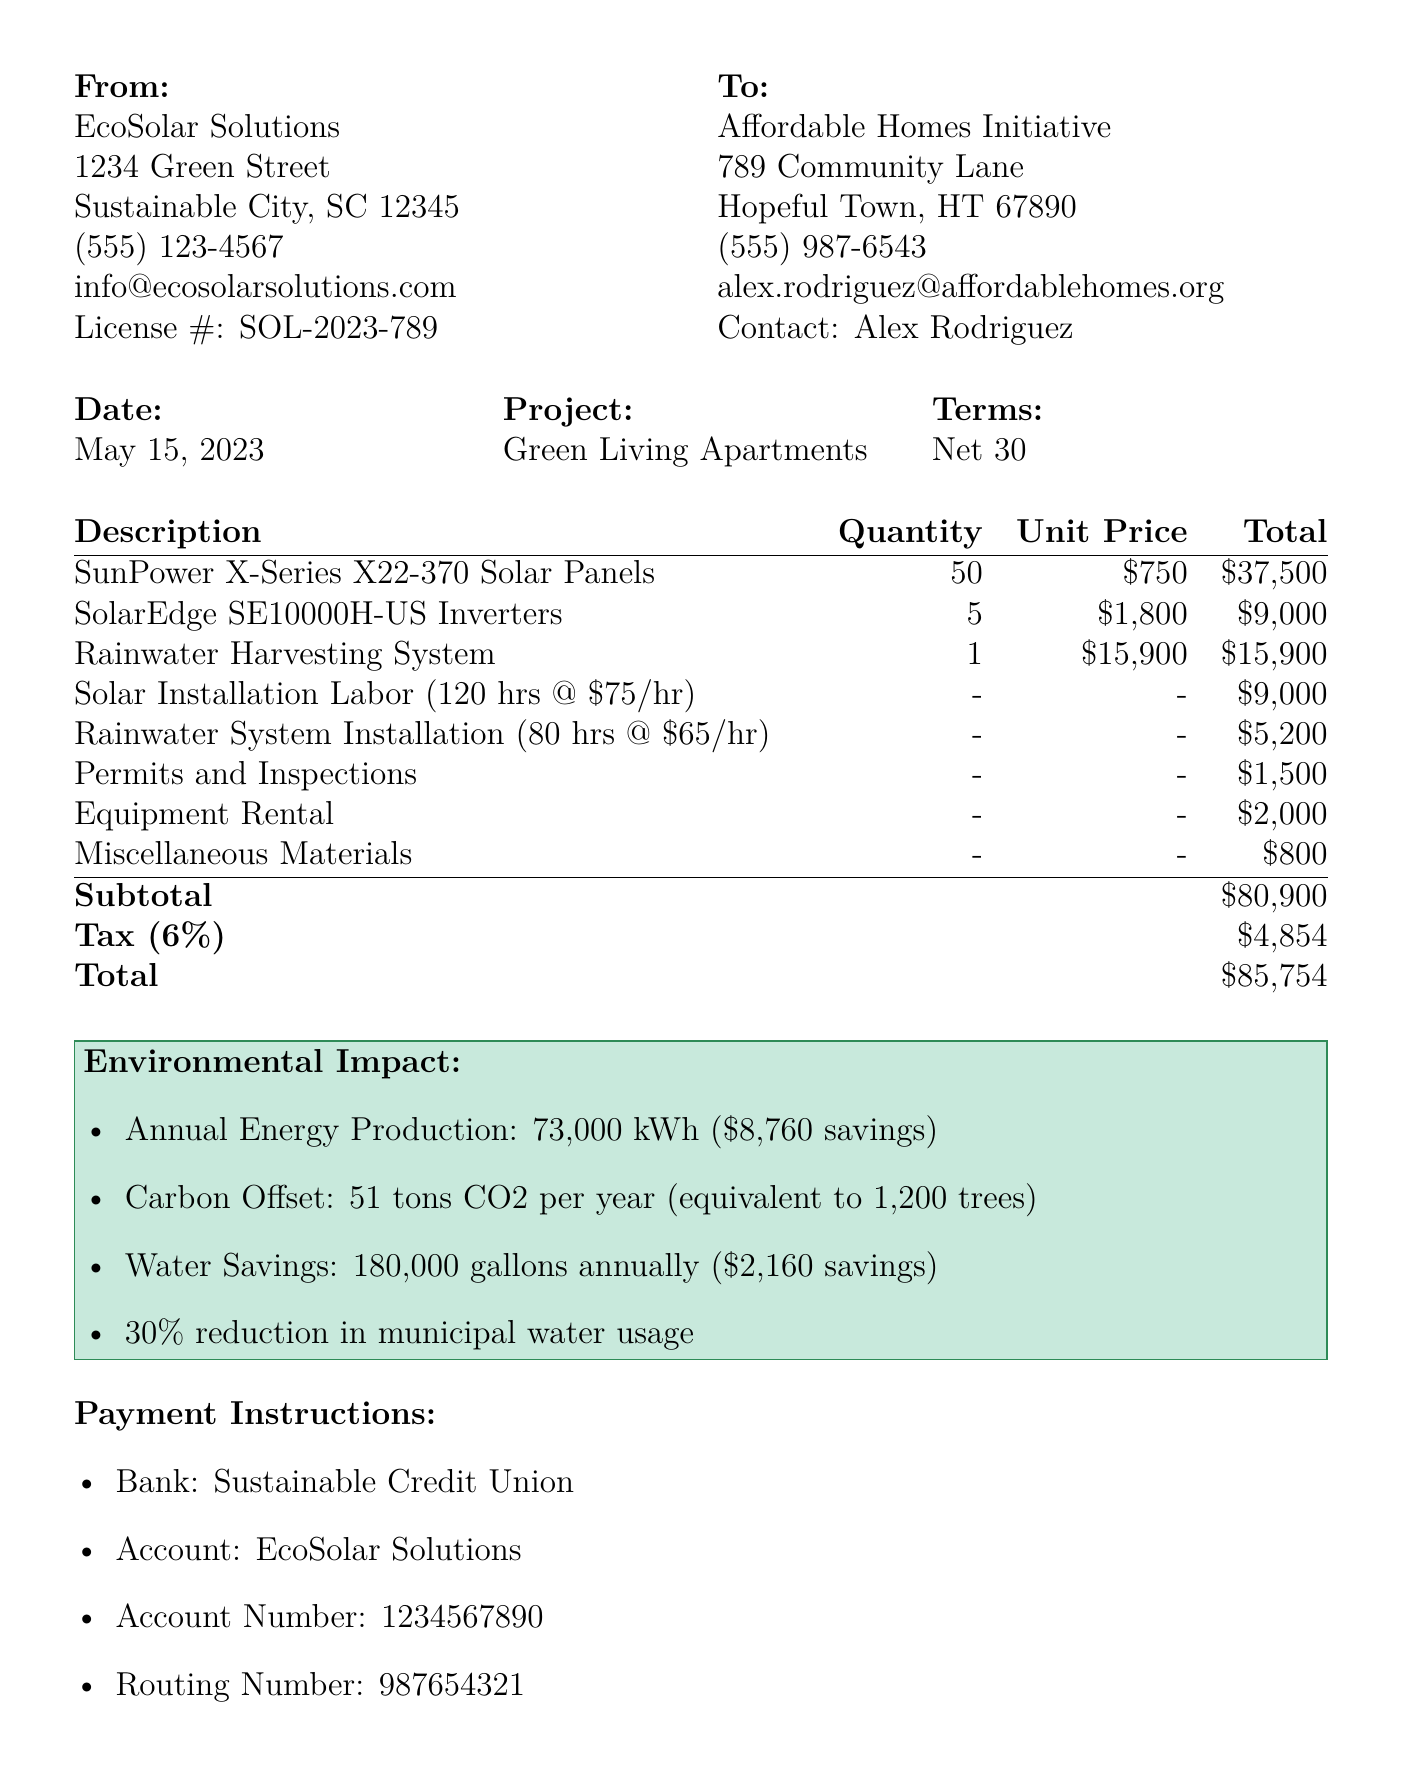What is the invoice number? The invoice number is specified under the invoice details section of the document.
Answer: INV-2023-0456 What is the total invoice amount? The total invoice amount is the final amount due at the bottom of the invoice, including tax.
Answer: $85,754 Who is the contact person for the client? The contact person's name is mentioned in the client information section.
Answer: Alex Rodriguez How many solar panels were installed? The quantity of solar panels installed is indicated in the solar panel installation section.
Answer: 50 What is the warranty period for the solar panels? The warranty period for the solar panels is stated in the solar panel installation section.
Answer: 25 years What brand of filtration system is used in the rainwater harvesting system? The brand of the filtration system is specified within the rainwater system components.
Answer: RainHarvest Systems What is the estimated annual savings from the energy production? The estimated annual savings is mentioned in the energy savings estimate.
Answer: $8,760 How many gallons of water can be saved annually? The annual water savings is noted in the water conservation estimate section.
Answer: 180,000 gallons What is the tax rate applied to the invoice? The tax rate is indicated in the total invoice amount section.
Answer: 6% 